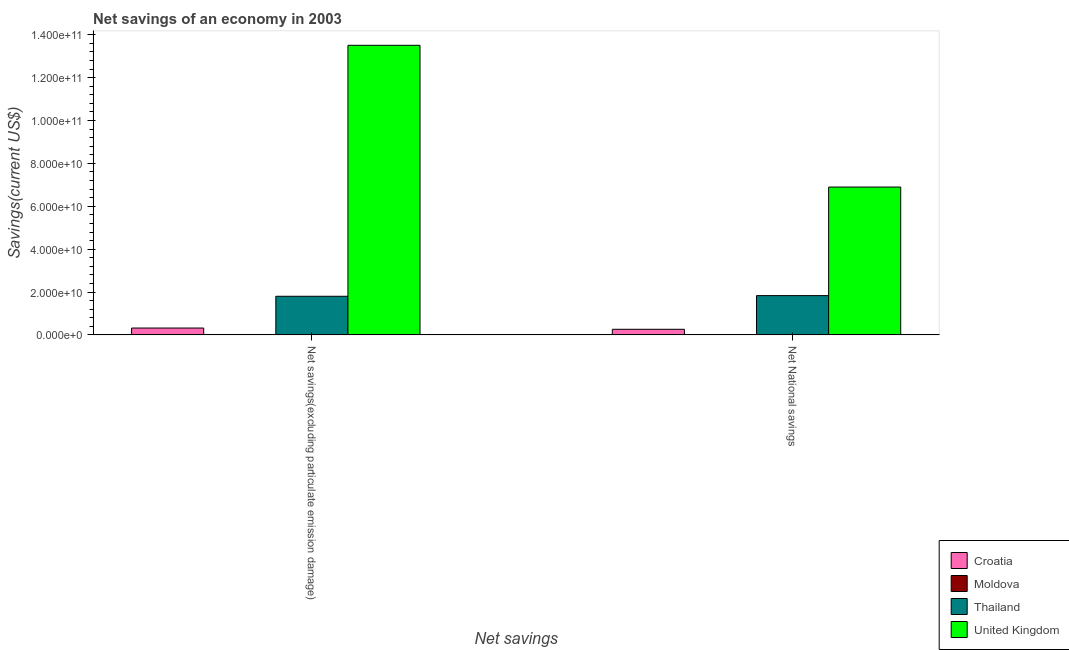Are the number of bars per tick equal to the number of legend labels?
Your answer should be very brief. Yes. Are the number of bars on each tick of the X-axis equal?
Keep it short and to the point. Yes. What is the label of the 1st group of bars from the left?
Offer a terse response. Net savings(excluding particulate emission damage). What is the net savings(excluding particulate emission damage) in United Kingdom?
Give a very brief answer. 1.35e+11. Across all countries, what is the maximum net savings(excluding particulate emission damage)?
Provide a succinct answer. 1.35e+11. Across all countries, what is the minimum net national savings?
Provide a short and direct response. 7.78e+07. In which country was the net national savings minimum?
Your answer should be very brief. Moldova. What is the total net national savings in the graph?
Provide a succinct answer. 9.00e+1. What is the difference between the net savings(excluding particulate emission damage) in Croatia and that in Moldova?
Your answer should be very brief. 3.01e+09. What is the difference between the net national savings in Croatia and the net savings(excluding particulate emission damage) in Thailand?
Offer a terse response. -1.54e+1. What is the average net national savings per country?
Provide a succinct answer. 2.25e+1. What is the difference between the net national savings and net savings(excluding particulate emission damage) in United Kingdom?
Provide a succinct answer. -6.61e+1. In how many countries, is the net savings(excluding particulate emission damage) greater than 100000000000 US$?
Provide a short and direct response. 1. What is the ratio of the net national savings in United Kingdom to that in Thailand?
Your answer should be compact. 3.76. In how many countries, is the net national savings greater than the average net national savings taken over all countries?
Provide a succinct answer. 1. What does the 2nd bar from the left in Net savings(excluding particulate emission damage) represents?
Ensure brevity in your answer.  Moldova. What does the 4th bar from the right in Net savings(excluding particulate emission damage) represents?
Give a very brief answer. Croatia. How many bars are there?
Provide a short and direct response. 8. Are all the bars in the graph horizontal?
Ensure brevity in your answer.  No. How many countries are there in the graph?
Give a very brief answer. 4. What is the difference between two consecutive major ticks on the Y-axis?
Your answer should be very brief. 2.00e+1. Are the values on the major ticks of Y-axis written in scientific E-notation?
Your response must be concise. Yes. Does the graph contain grids?
Offer a terse response. No. What is the title of the graph?
Your answer should be very brief. Net savings of an economy in 2003. Does "Palau" appear as one of the legend labels in the graph?
Give a very brief answer. No. What is the label or title of the X-axis?
Keep it short and to the point. Net savings. What is the label or title of the Y-axis?
Your answer should be very brief. Savings(current US$). What is the Savings(current US$) in Croatia in Net savings(excluding particulate emission damage)?
Offer a terse response. 3.20e+09. What is the Savings(current US$) of Moldova in Net savings(excluding particulate emission damage)?
Ensure brevity in your answer.  1.90e+08. What is the Savings(current US$) of Thailand in Net savings(excluding particulate emission damage)?
Provide a succinct answer. 1.80e+1. What is the Savings(current US$) in United Kingdom in Net savings(excluding particulate emission damage)?
Offer a very short reply. 1.35e+11. What is the Savings(current US$) in Croatia in Net National savings?
Give a very brief answer. 2.61e+09. What is the Savings(current US$) of Moldova in Net National savings?
Offer a very short reply. 7.78e+07. What is the Savings(current US$) of Thailand in Net National savings?
Give a very brief answer. 1.83e+1. What is the Savings(current US$) of United Kingdom in Net National savings?
Offer a terse response. 6.90e+1. Across all Net savings, what is the maximum Savings(current US$) of Croatia?
Provide a short and direct response. 3.20e+09. Across all Net savings, what is the maximum Savings(current US$) of Moldova?
Keep it short and to the point. 1.90e+08. Across all Net savings, what is the maximum Savings(current US$) in Thailand?
Provide a short and direct response. 1.83e+1. Across all Net savings, what is the maximum Savings(current US$) of United Kingdom?
Your answer should be very brief. 1.35e+11. Across all Net savings, what is the minimum Savings(current US$) of Croatia?
Provide a succinct answer. 2.61e+09. Across all Net savings, what is the minimum Savings(current US$) of Moldova?
Ensure brevity in your answer.  7.78e+07. Across all Net savings, what is the minimum Savings(current US$) of Thailand?
Your answer should be compact. 1.80e+1. Across all Net savings, what is the minimum Savings(current US$) of United Kingdom?
Provide a short and direct response. 6.90e+1. What is the total Savings(current US$) of Croatia in the graph?
Your answer should be very brief. 5.81e+09. What is the total Savings(current US$) in Moldova in the graph?
Your answer should be compact. 2.68e+08. What is the total Savings(current US$) in Thailand in the graph?
Provide a succinct answer. 3.63e+1. What is the total Savings(current US$) in United Kingdom in the graph?
Offer a very short reply. 2.04e+11. What is the difference between the Savings(current US$) of Croatia in Net savings(excluding particulate emission damage) and that in Net National savings?
Offer a very short reply. 5.87e+08. What is the difference between the Savings(current US$) in Moldova in Net savings(excluding particulate emission damage) and that in Net National savings?
Your response must be concise. 1.12e+08. What is the difference between the Savings(current US$) of Thailand in Net savings(excluding particulate emission damage) and that in Net National savings?
Keep it short and to the point. -3.07e+08. What is the difference between the Savings(current US$) of United Kingdom in Net savings(excluding particulate emission damage) and that in Net National savings?
Keep it short and to the point. 6.61e+1. What is the difference between the Savings(current US$) of Croatia in Net savings(excluding particulate emission damage) and the Savings(current US$) of Moldova in Net National savings?
Keep it short and to the point. 3.12e+09. What is the difference between the Savings(current US$) in Croatia in Net savings(excluding particulate emission damage) and the Savings(current US$) in Thailand in Net National savings?
Your answer should be compact. -1.51e+1. What is the difference between the Savings(current US$) in Croatia in Net savings(excluding particulate emission damage) and the Savings(current US$) in United Kingdom in Net National savings?
Your answer should be compact. -6.58e+1. What is the difference between the Savings(current US$) of Moldova in Net savings(excluding particulate emission damage) and the Savings(current US$) of Thailand in Net National savings?
Offer a very short reply. -1.81e+1. What is the difference between the Savings(current US$) in Moldova in Net savings(excluding particulate emission damage) and the Savings(current US$) in United Kingdom in Net National savings?
Offer a very short reply. -6.88e+1. What is the difference between the Savings(current US$) in Thailand in Net savings(excluding particulate emission damage) and the Savings(current US$) in United Kingdom in Net National savings?
Offer a very short reply. -5.10e+1. What is the average Savings(current US$) of Croatia per Net savings?
Your answer should be compact. 2.91e+09. What is the average Savings(current US$) of Moldova per Net savings?
Offer a very short reply. 1.34e+08. What is the average Savings(current US$) of Thailand per Net savings?
Keep it short and to the point. 1.82e+1. What is the average Savings(current US$) of United Kingdom per Net savings?
Provide a short and direct response. 1.02e+11. What is the difference between the Savings(current US$) in Croatia and Savings(current US$) in Moldova in Net savings(excluding particulate emission damage)?
Provide a succinct answer. 3.01e+09. What is the difference between the Savings(current US$) in Croatia and Savings(current US$) in Thailand in Net savings(excluding particulate emission damage)?
Make the answer very short. -1.48e+1. What is the difference between the Savings(current US$) of Croatia and Savings(current US$) of United Kingdom in Net savings(excluding particulate emission damage)?
Your answer should be very brief. -1.32e+11. What is the difference between the Savings(current US$) of Moldova and Savings(current US$) of Thailand in Net savings(excluding particulate emission damage)?
Offer a terse response. -1.78e+1. What is the difference between the Savings(current US$) in Moldova and Savings(current US$) in United Kingdom in Net savings(excluding particulate emission damage)?
Give a very brief answer. -1.35e+11. What is the difference between the Savings(current US$) of Thailand and Savings(current US$) of United Kingdom in Net savings(excluding particulate emission damage)?
Provide a succinct answer. -1.17e+11. What is the difference between the Savings(current US$) of Croatia and Savings(current US$) of Moldova in Net National savings?
Provide a short and direct response. 2.53e+09. What is the difference between the Savings(current US$) of Croatia and Savings(current US$) of Thailand in Net National savings?
Your response must be concise. -1.57e+1. What is the difference between the Savings(current US$) in Croatia and Savings(current US$) in United Kingdom in Net National savings?
Make the answer very short. -6.64e+1. What is the difference between the Savings(current US$) in Moldova and Savings(current US$) in Thailand in Net National savings?
Your response must be concise. -1.82e+1. What is the difference between the Savings(current US$) of Moldova and Savings(current US$) of United Kingdom in Net National savings?
Your answer should be compact. -6.89e+1. What is the difference between the Savings(current US$) of Thailand and Savings(current US$) of United Kingdom in Net National savings?
Your answer should be very brief. -5.07e+1. What is the ratio of the Savings(current US$) in Croatia in Net savings(excluding particulate emission damage) to that in Net National savings?
Keep it short and to the point. 1.22. What is the ratio of the Savings(current US$) in Moldova in Net savings(excluding particulate emission damage) to that in Net National savings?
Your answer should be compact. 2.44. What is the ratio of the Savings(current US$) in Thailand in Net savings(excluding particulate emission damage) to that in Net National savings?
Provide a short and direct response. 0.98. What is the ratio of the Savings(current US$) of United Kingdom in Net savings(excluding particulate emission damage) to that in Net National savings?
Your response must be concise. 1.96. What is the difference between the highest and the second highest Savings(current US$) in Croatia?
Ensure brevity in your answer.  5.87e+08. What is the difference between the highest and the second highest Savings(current US$) of Moldova?
Provide a short and direct response. 1.12e+08. What is the difference between the highest and the second highest Savings(current US$) of Thailand?
Provide a short and direct response. 3.07e+08. What is the difference between the highest and the second highest Savings(current US$) in United Kingdom?
Provide a short and direct response. 6.61e+1. What is the difference between the highest and the lowest Savings(current US$) in Croatia?
Provide a succinct answer. 5.87e+08. What is the difference between the highest and the lowest Savings(current US$) of Moldova?
Make the answer very short. 1.12e+08. What is the difference between the highest and the lowest Savings(current US$) in Thailand?
Make the answer very short. 3.07e+08. What is the difference between the highest and the lowest Savings(current US$) of United Kingdom?
Offer a very short reply. 6.61e+1. 